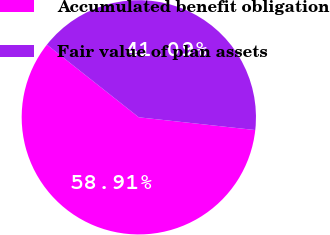Convert chart to OTSL. <chart><loc_0><loc_0><loc_500><loc_500><pie_chart><fcel>Accumulated benefit obligation<fcel>Fair value of plan assets<nl><fcel>58.91%<fcel>41.09%<nl></chart> 